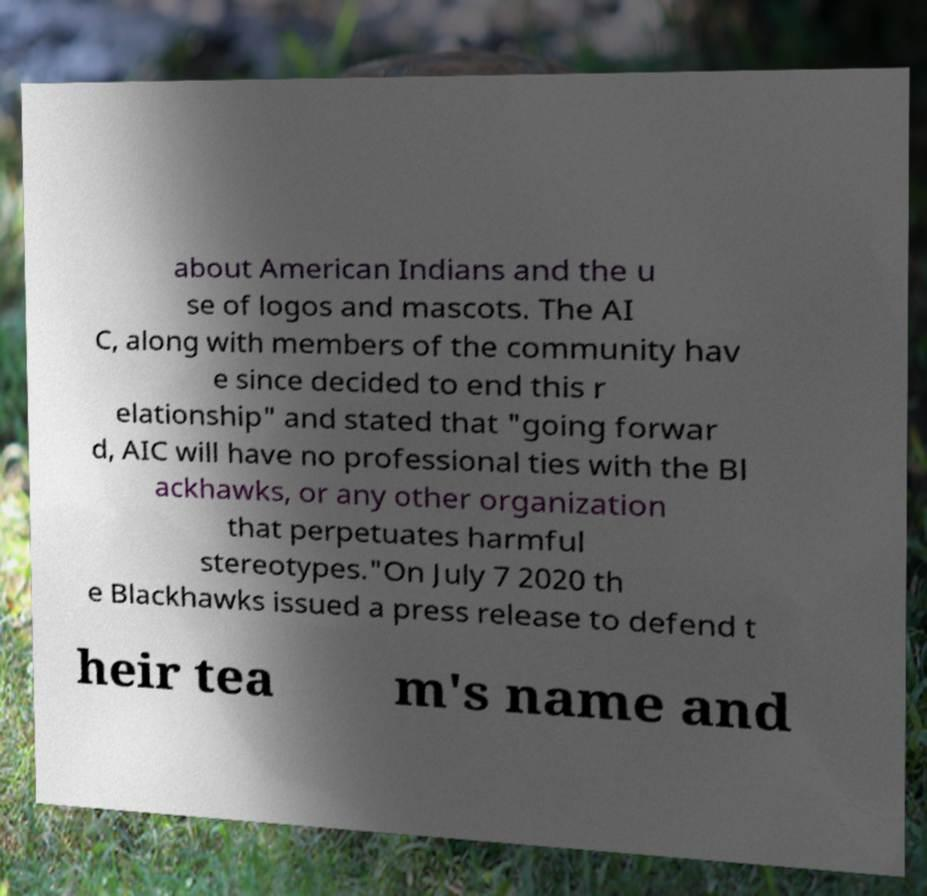Can you read and provide the text displayed in the image?This photo seems to have some interesting text. Can you extract and type it out for me? about American Indians and the u se of logos and mascots. The AI C, along with members of the community hav e since decided to end this r elationship" and stated that "going forwar d, AIC will have no professional ties with the Bl ackhawks, or any other organization that perpetuates harmful stereotypes."On July 7 2020 th e Blackhawks issued a press release to defend t heir tea m's name and 